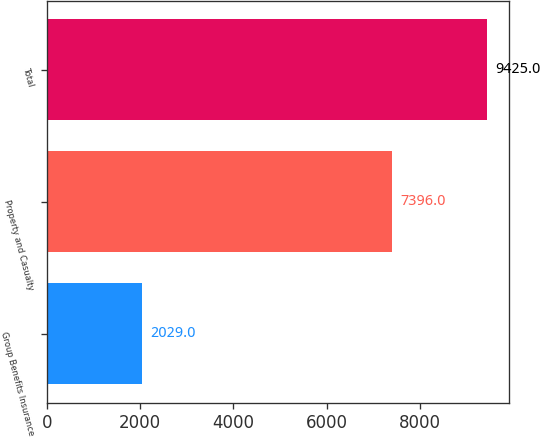Convert chart. <chart><loc_0><loc_0><loc_500><loc_500><bar_chart><fcel>Group Benefits Insurance<fcel>Property and Casualty<fcel>Total<nl><fcel>2029<fcel>7396<fcel>9425<nl></chart> 